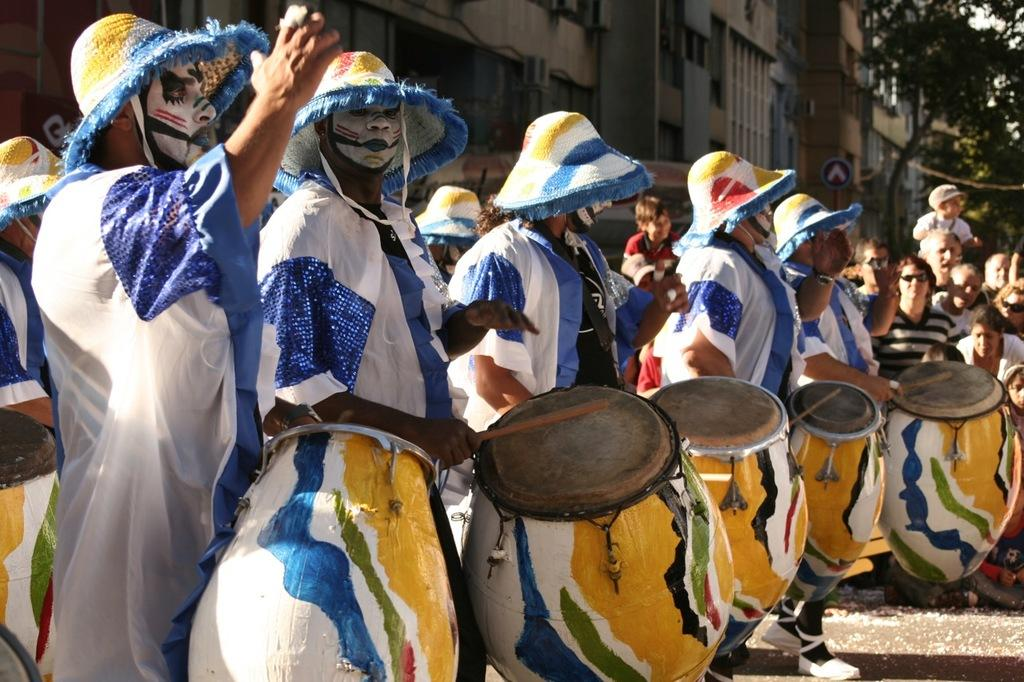What are the people in the image doing? The people in the image are standing and holding wooden musical instruments. What type of musical instruments are being held? Drums are among the musical instruments being held. What can be seen on the right side of the image? There are trees on the right side of the image. What type of structures are visible in the image? There are buildings visible in the image. What advertisement can be seen on the gate in the image? There is no gate or advertisement present in the image. How many cents are visible on the musical instruments in the image? There are no cents depicted on the musical instruments in the image. 